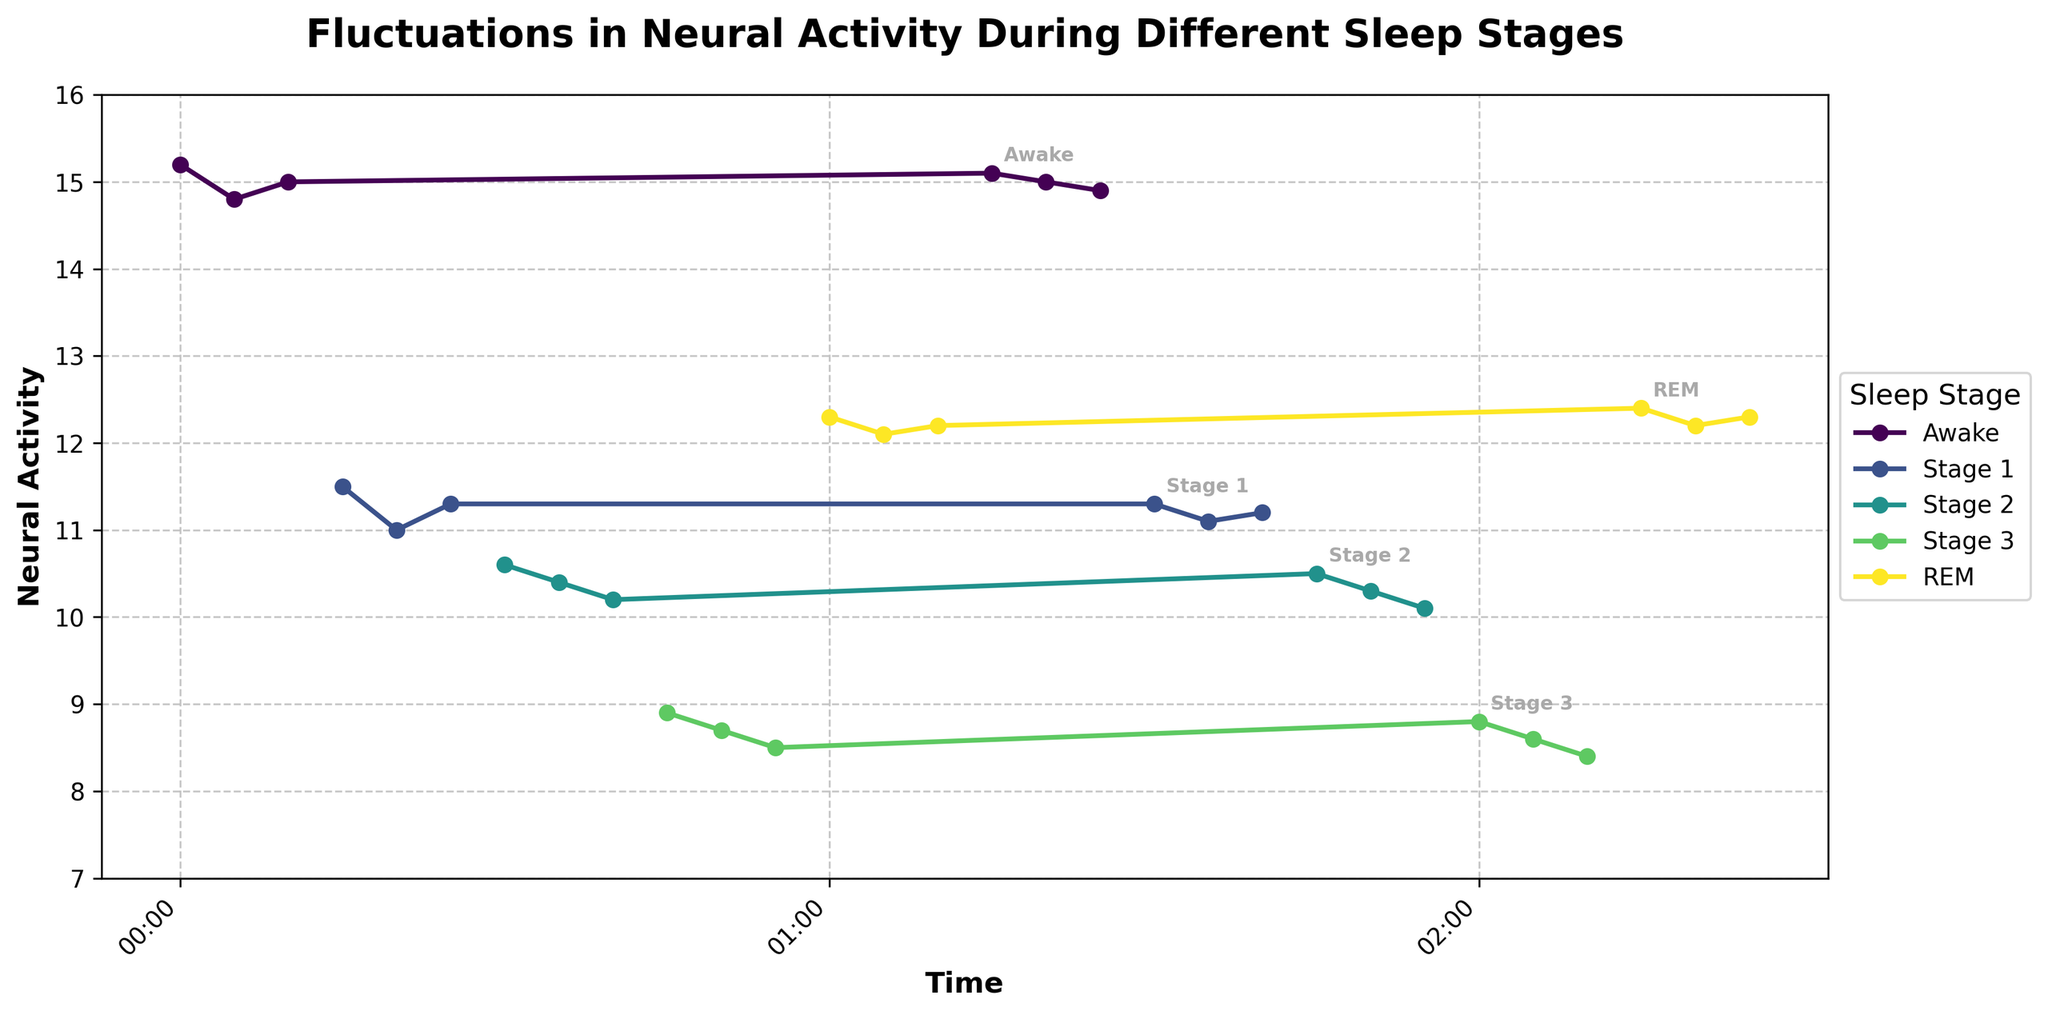what's the title of the plot? The title is usually located at the top center of the plot. In this case, the title at the top of the plot reads "Fluctuations in Neural Activity During Different Sleep Stages".
Answer: Fluctuations in Neural Activity During Different Sleep Stages what are the labels of the x and y axes? The labels of the x and y axes are provided near the axes. The x-axis is labeled "Time" and the y-axis is labeled "Neural Activity".
Answer: Time, Neural Activity which sleep stage has the highest neural activity overall? From the plot, we can observe the y-values representing neural activity. The "Awake" stage shows the highest values consistently, around 15.0.
Answer: Awake how does neural activity change from Stage 1 to Stage 3? Comparing the data points from Stage 1 to Stage 3, neural activity decreases. Stage 1 ranges around 11.0 to 11.5, while Stage 3 ranges around 8.4 to 8.9.
Answer: Decreases what is the time range covered by the plot? The x-axis, labeled with time, ranges from "00:00" to "02:25", showing the time covered in hours and minutes.
Answer: 00:00 to 02:25 what is the pattern of neural activity during REM stages? When examining the labeled "REM" stages, neural activity shows a consistent pattern around the 12.2 to 12.4 range.
Answer: Consistent around 12.2 to 12.4 which sleep stage has the closest neural activity values to REM? Observing the plot, the neural activity during Stage 1, which ranges around 11.0 to 11.5, is closest to REM activities which are around 12.2 to 12.4.
Answer: Stage 1 how does the duration of the Awake stage appearances compare to the REM stage? By counting the data points for each stage, "Awake" appears for six time intervals, and "REM" also appears for six intervals, indicating they have similar durations.
Answer: Similar what is the average neural activity level during Awake periods? Summing the neural activity during "Awake" periods and dividing by the number of instances: (15.2 + 14.8 + 15.0 + 15.1 + 15.0 + 14.9) / 6 = 15.0.
Answer: 15.0 how does neural activity change during the transition from Awake to Stage 1? The plot shows that neural activity drops significantly from around 15.0 during the Awake state to around 11.0 during Stage 1.
Answer: Drops significantly 